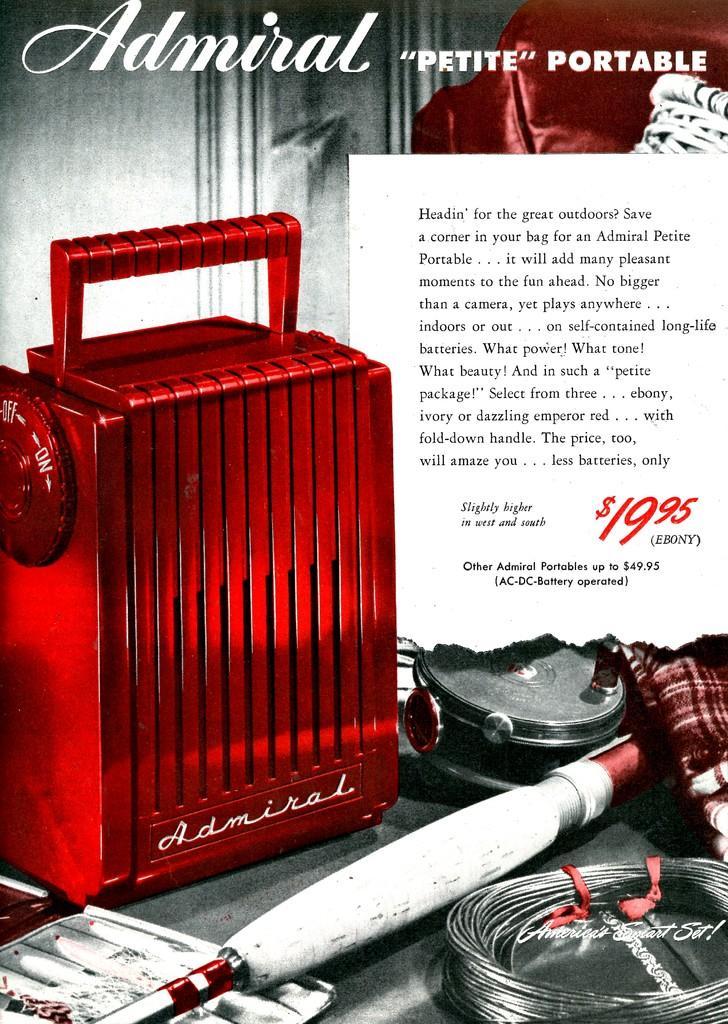How would you summarize this image in a sentence or two? In the foreground of this edited image, we can see text on the top and right. On the left, there is a speaker box. On the bottom, there is a pole like structure, a wire bundle and few objects. We can also see an electronic device and a red color cloth on the right. 